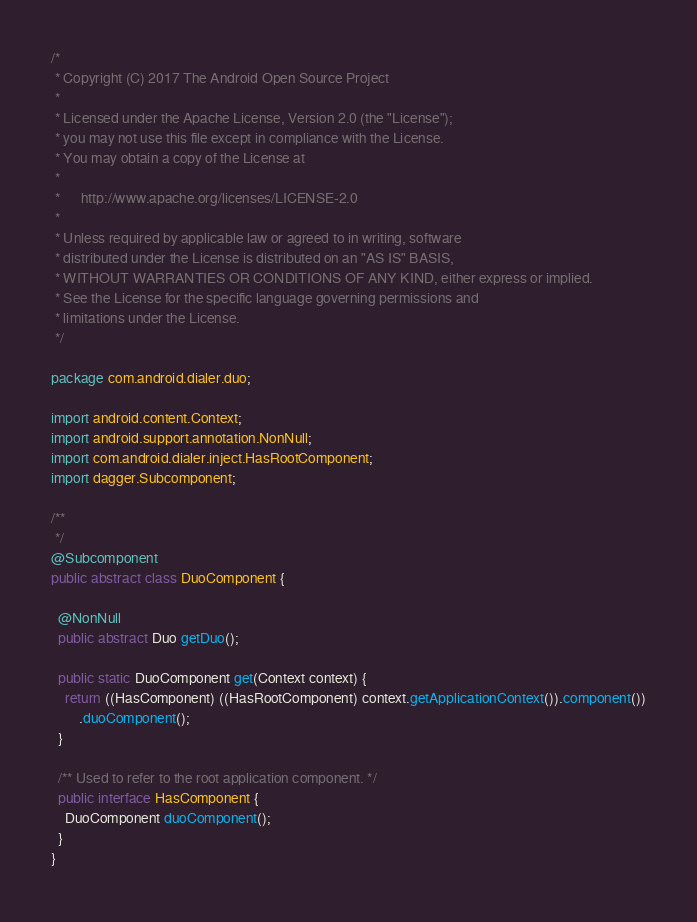<code> <loc_0><loc_0><loc_500><loc_500><_Java_>/*
 * Copyright (C) 2017 The Android Open Source Project
 *
 * Licensed under the Apache License, Version 2.0 (the "License");
 * you may not use this file except in compliance with the License.
 * You may obtain a copy of the License at
 *
 *      http://www.apache.org/licenses/LICENSE-2.0
 *
 * Unless required by applicable law or agreed to in writing, software
 * distributed under the License is distributed on an "AS IS" BASIS,
 * WITHOUT WARRANTIES OR CONDITIONS OF ANY KIND, either express or implied.
 * See the License for the specific language governing permissions and
 * limitations under the License.
 */

package com.android.dialer.duo;

import android.content.Context;
import android.support.annotation.NonNull;
import com.android.dialer.inject.HasRootComponent;
import dagger.Subcomponent;

/**
 */
@Subcomponent
public abstract class DuoComponent {

  @NonNull
  public abstract Duo getDuo();

  public static DuoComponent get(Context context) {
    return ((HasComponent) ((HasRootComponent) context.getApplicationContext()).component())
        .duoComponent();
  }

  /** Used to refer to the root application component. */
  public interface HasComponent {
    DuoComponent duoComponent();
  }
}
</code> 